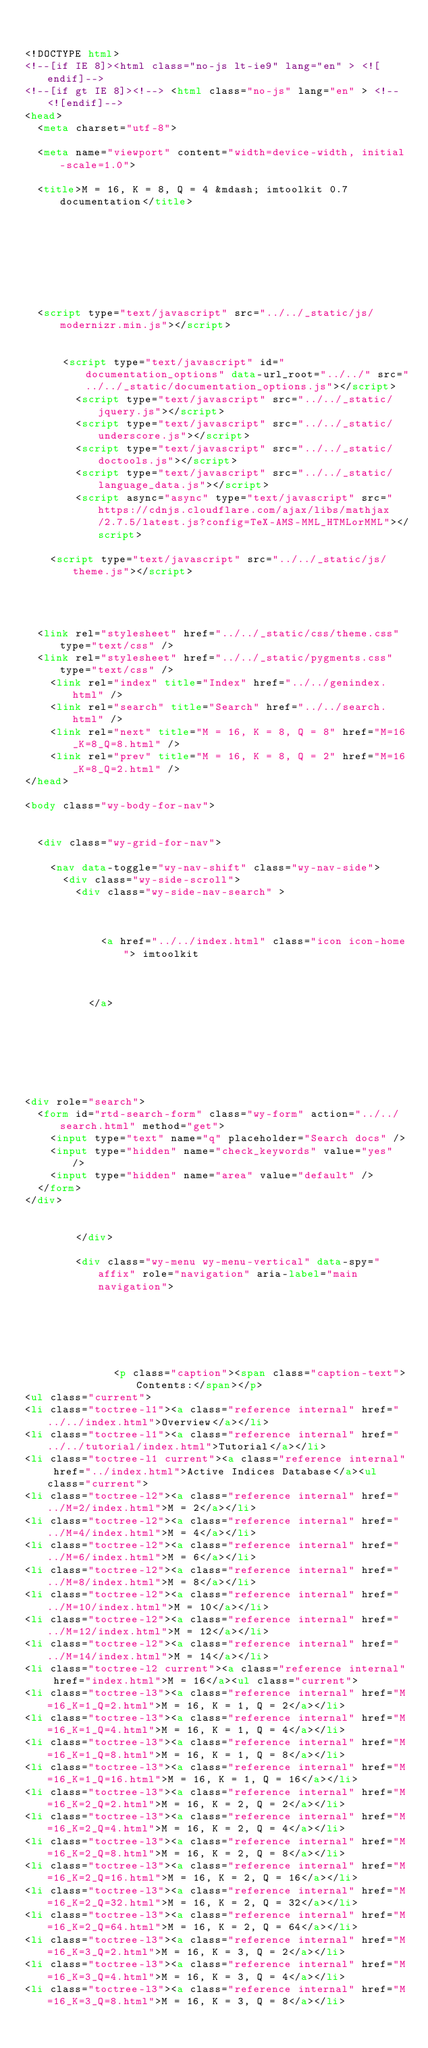Convert code to text. <code><loc_0><loc_0><loc_500><loc_500><_HTML_>

<!DOCTYPE html>
<!--[if IE 8]><html class="no-js lt-ie9" lang="en" > <![endif]-->
<!--[if gt IE 8]><!--> <html class="no-js" lang="en" > <!--<![endif]-->
<head>
  <meta charset="utf-8">
  
  <meta name="viewport" content="width=device-width, initial-scale=1.0">
  
  <title>M = 16, K = 8, Q = 4 &mdash; imtoolkit 0.7 documentation</title>
  

  
  
  
  

  
  <script type="text/javascript" src="../../_static/js/modernizr.min.js"></script>
  
    
      <script type="text/javascript" id="documentation_options" data-url_root="../../" src="../../_static/documentation_options.js"></script>
        <script type="text/javascript" src="../../_static/jquery.js"></script>
        <script type="text/javascript" src="../../_static/underscore.js"></script>
        <script type="text/javascript" src="../../_static/doctools.js"></script>
        <script type="text/javascript" src="../../_static/language_data.js"></script>
        <script async="async" type="text/javascript" src="https://cdnjs.cloudflare.com/ajax/libs/mathjax/2.7.5/latest.js?config=TeX-AMS-MML_HTMLorMML"></script>
    
    <script type="text/javascript" src="../../_static/js/theme.js"></script>

    

  
  <link rel="stylesheet" href="../../_static/css/theme.css" type="text/css" />
  <link rel="stylesheet" href="../../_static/pygments.css" type="text/css" />
    <link rel="index" title="Index" href="../../genindex.html" />
    <link rel="search" title="Search" href="../../search.html" />
    <link rel="next" title="M = 16, K = 8, Q = 8" href="M=16_K=8_Q=8.html" />
    <link rel="prev" title="M = 16, K = 8, Q = 2" href="M=16_K=8_Q=2.html" /> 
</head>

<body class="wy-body-for-nav">

   
  <div class="wy-grid-for-nav">
    
    <nav data-toggle="wy-nav-shift" class="wy-nav-side">
      <div class="wy-side-scroll">
        <div class="wy-side-nav-search" >
          

          
            <a href="../../index.html" class="icon icon-home"> imtoolkit
          

          
          </a>

          
            
            
          

          
<div role="search">
  <form id="rtd-search-form" class="wy-form" action="../../search.html" method="get">
    <input type="text" name="q" placeholder="Search docs" />
    <input type="hidden" name="check_keywords" value="yes" />
    <input type="hidden" name="area" value="default" />
  </form>
</div>

          
        </div>

        <div class="wy-menu wy-menu-vertical" data-spy="affix" role="navigation" aria-label="main navigation">
          
            
            
              
            
            
              <p class="caption"><span class="caption-text">Contents:</span></p>
<ul class="current">
<li class="toctree-l1"><a class="reference internal" href="../../index.html">Overview</a></li>
<li class="toctree-l1"><a class="reference internal" href="../../tutorial/index.html">Tutorial</a></li>
<li class="toctree-l1 current"><a class="reference internal" href="../index.html">Active Indices Database</a><ul class="current">
<li class="toctree-l2"><a class="reference internal" href="../M=2/index.html">M = 2</a></li>
<li class="toctree-l2"><a class="reference internal" href="../M=4/index.html">M = 4</a></li>
<li class="toctree-l2"><a class="reference internal" href="../M=6/index.html">M = 6</a></li>
<li class="toctree-l2"><a class="reference internal" href="../M=8/index.html">M = 8</a></li>
<li class="toctree-l2"><a class="reference internal" href="../M=10/index.html">M = 10</a></li>
<li class="toctree-l2"><a class="reference internal" href="../M=12/index.html">M = 12</a></li>
<li class="toctree-l2"><a class="reference internal" href="../M=14/index.html">M = 14</a></li>
<li class="toctree-l2 current"><a class="reference internal" href="index.html">M = 16</a><ul class="current">
<li class="toctree-l3"><a class="reference internal" href="M=16_K=1_Q=2.html">M = 16, K = 1, Q = 2</a></li>
<li class="toctree-l3"><a class="reference internal" href="M=16_K=1_Q=4.html">M = 16, K = 1, Q = 4</a></li>
<li class="toctree-l3"><a class="reference internal" href="M=16_K=1_Q=8.html">M = 16, K = 1, Q = 8</a></li>
<li class="toctree-l3"><a class="reference internal" href="M=16_K=1_Q=16.html">M = 16, K = 1, Q = 16</a></li>
<li class="toctree-l3"><a class="reference internal" href="M=16_K=2_Q=2.html">M = 16, K = 2, Q = 2</a></li>
<li class="toctree-l3"><a class="reference internal" href="M=16_K=2_Q=4.html">M = 16, K = 2, Q = 4</a></li>
<li class="toctree-l3"><a class="reference internal" href="M=16_K=2_Q=8.html">M = 16, K = 2, Q = 8</a></li>
<li class="toctree-l3"><a class="reference internal" href="M=16_K=2_Q=16.html">M = 16, K = 2, Q = 16</a></li>
<li class="toctree-l3"><a class="reference internal" href="M=16_K=2_Q=32.html">M = 16, K = 2, Q = 32</a></li>
<li class="toctree-l3"><a class="reference internal" href="M=16_K=2_Q=64.html">M = 16, K = 2, Q = 64</a></li>
<li class="toctree-l3"><a class="reference internal" href="M=16_K=3_Q=2.html">M = 16, K = 3, Q = 2</a></li>
<li class="toctree-l3"><a class="reference internal" href="M=16_K=3_Q=4.html">M = 16, K = 3, Q = 4</a></li>
<li class="toctree-l3"><a class="reference internal" href="M=16_K=3_Q=8.html">M = 16, K = 3, Q = 8</a></li></code> 